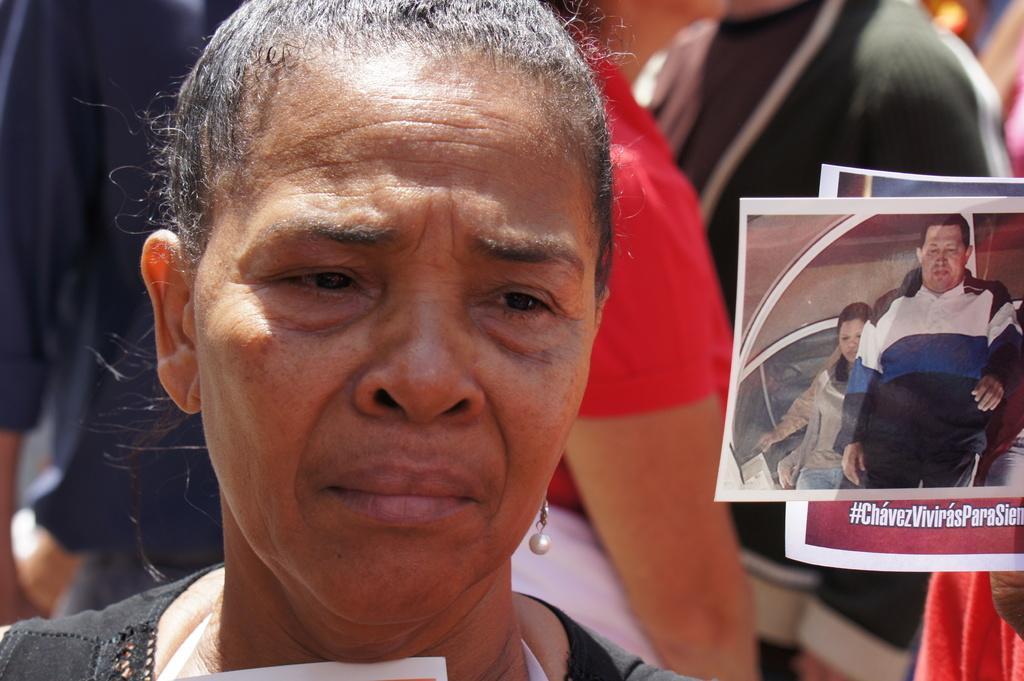In one or two sentences, can you explain what this image depicts? In front of the picture, we see the woman. I think she is crying. On the right side, we see the poster of a man and a woman. We see some text written on the poster. Behind her, we see many people are standing. 